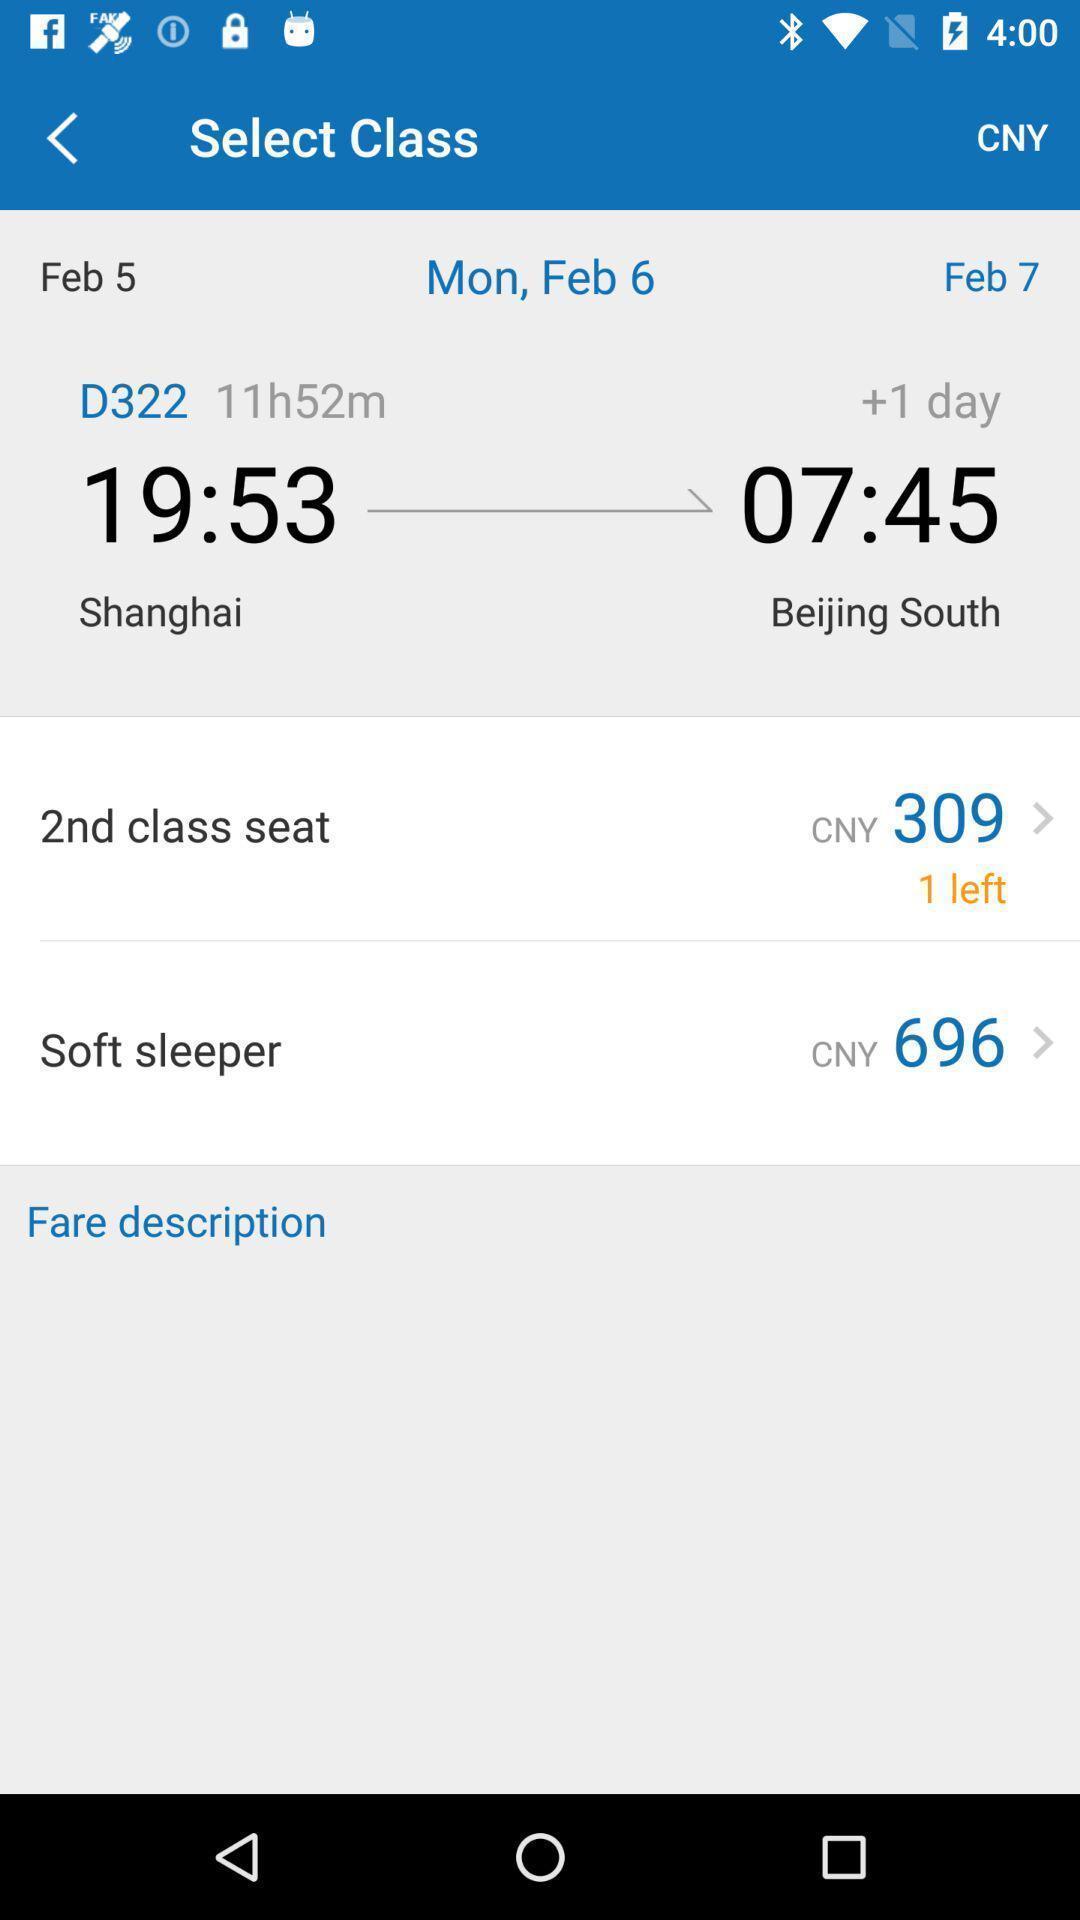Provide a description of this screenshot. Screen showing details of ticket in an travel application. 